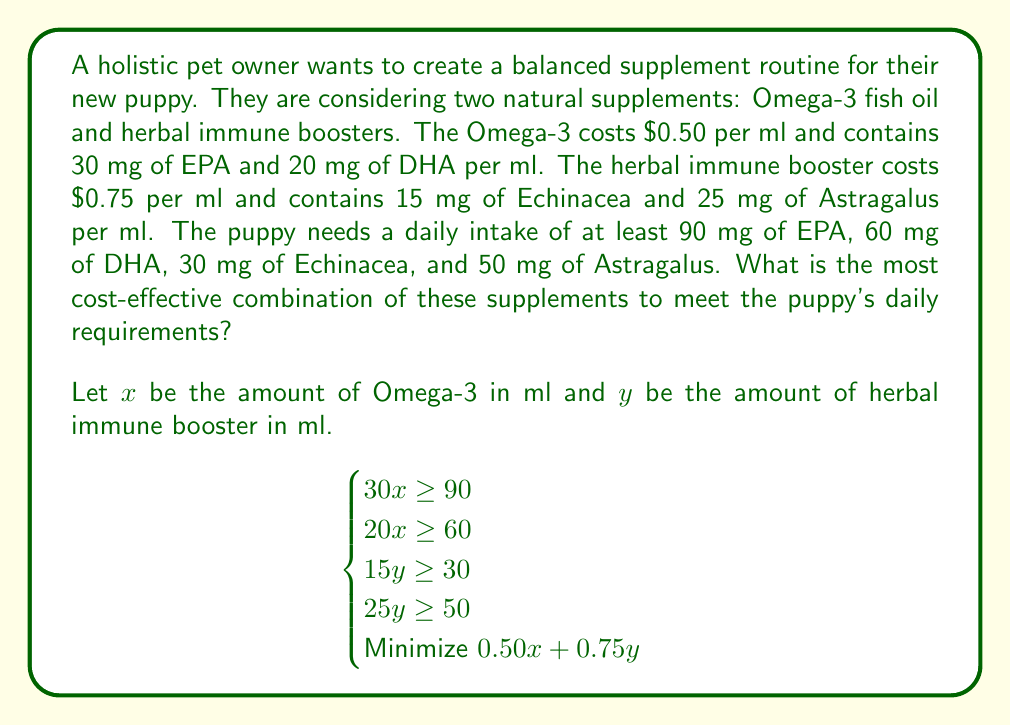Could you help me with this problem? To solve this system of equations and find the most cost-effective combination, we'll follow these steps:

1) First, let's simplify the inequalities:
   $$\begin{cases}
   x \geq 3 \\
   x \geq 3 \\
   y \geq 2 \\
   y \geq 2 \\
   \text{Minimize } 0.50x + 0.75y
   \end{cases}$$

2) We can see that $x \geq 3$ and $y \geq 2$ are the binding constraints.

3) Since we're trying to minimize the cost, we'll use the minimum values that satisfy these constraints:
   $x = 3$ and $y = 2$

4) Now, let's calculate the cost:
   Cost = $0.50x + 0.75y$
        = $0.50(3) + 0.75(2)$
        = $1.50 + 1.50$
        = $3.00

5) Therefore, the most cost-effective combination is:
   3 ml of Omega-3 fish oil
   2 ml of herbal immune booster

6) Let's verify that this meets all requirements:
   EPA: $30 * 3 = 90$ mg (meets 90 mg requirement)
   DHA: $20 * 3 = 60$ mg (meets 60 mg requirement)
   Echinacea: $15 * 2 = 30$ mg (meets 30 mg requirement)
   Astragalus: $25 * 2 = 50$ mg (meets 50 mg requirement)

This combination satisfies all nutritional requirements at the lowest possible cost.
Answer: The most cost-effective combination is 3 ml of Omega-3 fish oil and 2 ml of herbal immune booster, costing $3.00 per day. 